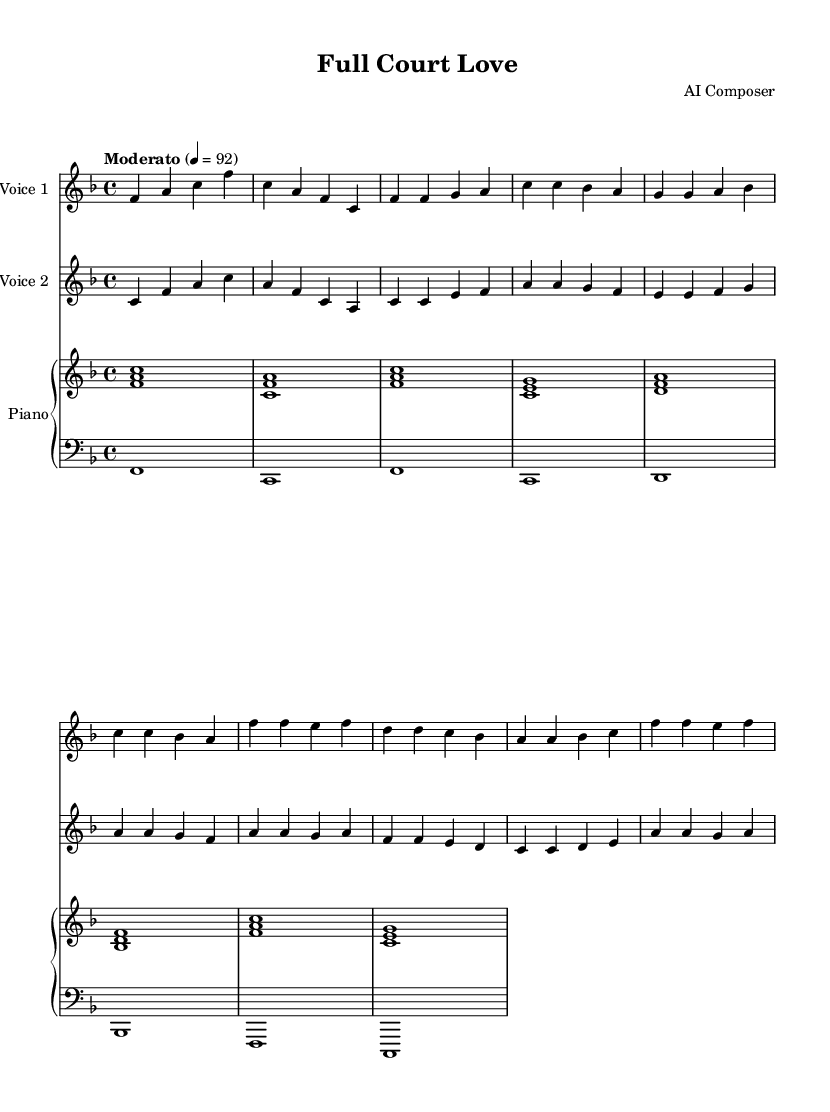What is the key signature of this music? The key signature shown at the beginning of the score indicates that there is one flat, which corresponds to the key of F major.
Answer: F major What is the time signature of this music? At the beginning of the score, the time signature is indicated as 4/4, meaning there are four beats in a measure and a quarter note gets one beat.
Answer: 4/4 What is the tempo marking for this piece? The tempo marking is written as "Moderato," which indicates a moderate pace. The specific tempo number given is 92 beats per minute.
Answer: Moderato What are the lyrics of the chorus? The lyrics for the chorus can be found under the specific staff for voice one, and they read "Full court love, we're the perfect team / Hand in hand, living out our dream."
Answer: Full court love, we're the perfect team / Hand in hand, living out our dream Which voice has the highest pitch at the chorus? By examining the chorus melody lines, voice one has the highest pitch, starting on an F note compared to the other voice.
Answer: Voice one How many measures are in the introduction? The introduction consists of two measures indicated at the beginning of the score before moving into the main sections of the song.
Answer: 2 measures What musical elements contribute to the romantic theme of the piece? The harmony, lyrical content celebrating teamwork, and the duet structure emphasize collaboration, evoking a romantic partnership akin to on-court chemistry.
Answer: Harmony and lyrical content 